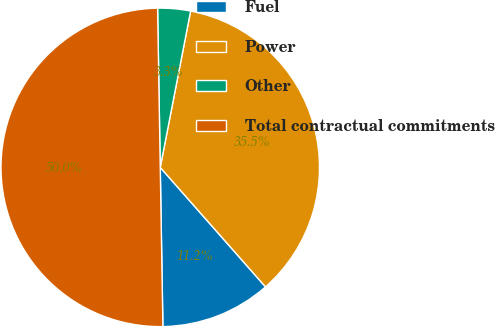<chart> <loc_0><loc_0><loc_500><loc_500><pie_chart><fcel>Fuel<fcel>Power<fcel>Other<fcel>Total contractual commitments<nl><fcel>11.23%<fcel>35.45%<fcel>3.32%<fcel>50.0%<nl></chart> 